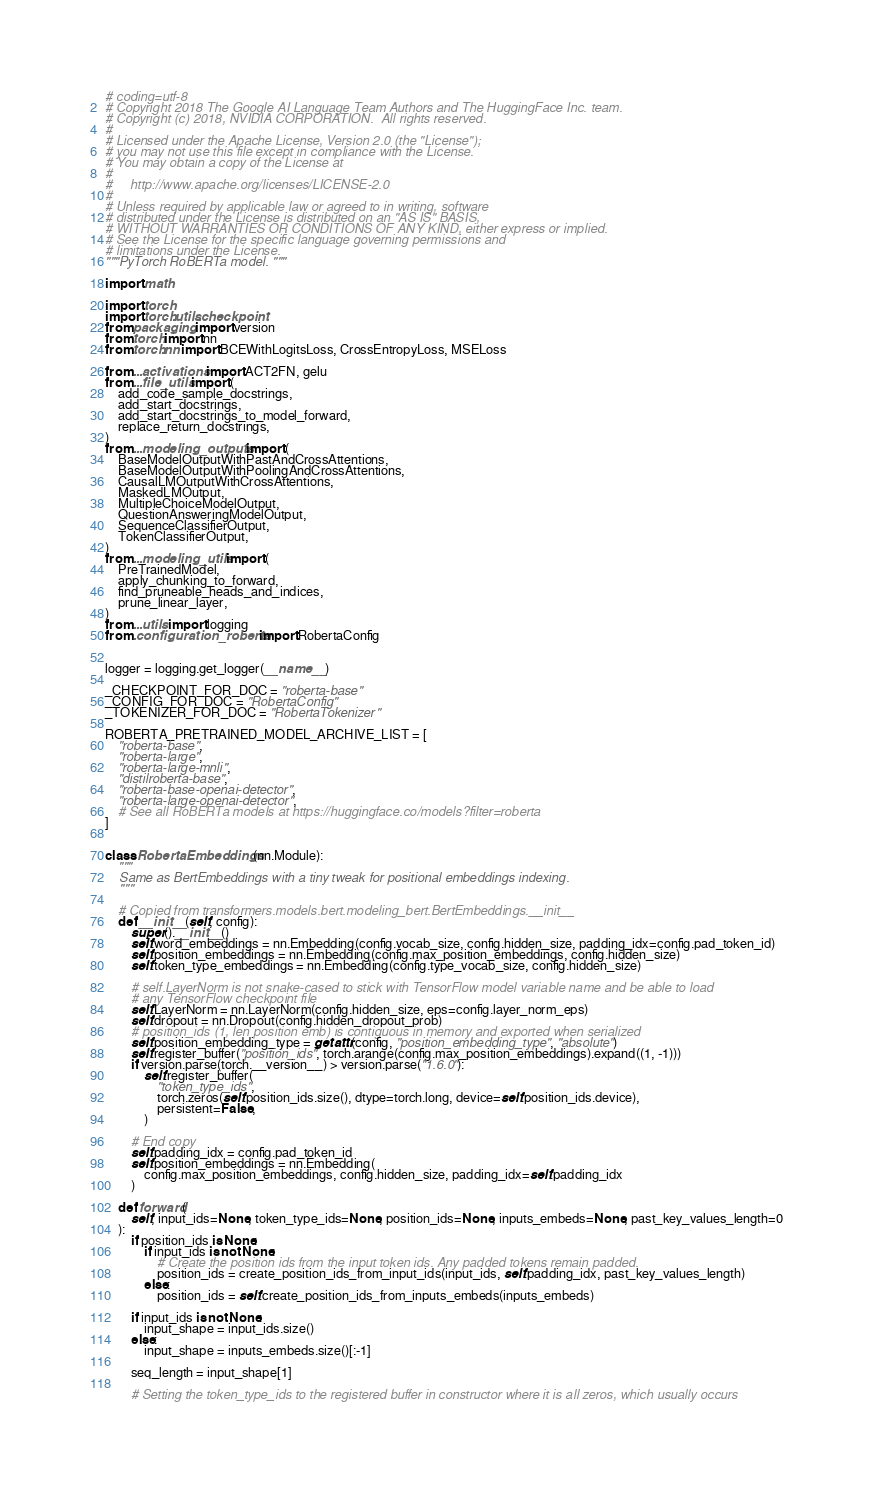<code> <loc_0><loc_0><loc_500><loc_500><_Python_># coding=utf-8
# Copyright 2018 The Google AI Language Team Authors and The HuggingFace Inc. team.
# Copyright (c) 2018, NVIDIA CORPORATION.  All rights reserved.
#
# Licensed under the Apache License, Version 2.0 (the "License");
# you may not use this file except in compliance with the License.
# You may obtain a copy of the License at
#
#     http://www.apache.org/licenses/LICENSE-2.0
#
# Unless required by applicable law or agreed to in writing, software
# distributed under the License is distributed on an "AS IS" BASIS,
# WITHOUT WARRANTIES OR CONDITIONS OF ANY KIND, either express or implied.
# See the License for the specific language governing permissions and
# limitations under the License.
"""PyTorch RoBERTa model. """

import math

import torch
import torch.utils.checkpoint
from packaging import version
from torch import nn
from torch.nn import BCEWithLogitsLoss, CrossEntropyLoss, MSELoss

from ...activations import ACT2FN, gelu
from ...file_utils import (
    add_code_sample_docstrings,
    add_start_docstrings,
    add_start_docstrings_to_model_forward,
    replace_return_docstrings,
)
from ...modeling_outputs import (
    BaseModelOutputWithPastAndCrossAttentions,
    BaseModelOutputWithPoolingAndCrossAttentions,
    CausalLMOutputWithCrossAttentions,
    MaskedLMOutput,
    MultipleChoiceModelOutput,
    QuestionAnsweringModelOutput,
    SequenceClassifierOutput,
    TokenClassifierOutput,
)
from ...modeling_utils import (
    PreTrainedModel,
    apply_chunking_to_forward,
    find_pruneable_heads_and_indices,
    prune_linear_layer,
)
from ...utils import logging
from .configuration_roberta import RobertaConfig


logger = logging.get_logger(__name__)

_CHECKPOINT_FOR_DOC = "roberta-base"
_CONFIG_FOR_DOC = "RobertaConfig"
_TOKENIZER_FOR_DOC = "RobertaTokenizer"

ROBERTA_PRETRAINED_MODEL_ARCHIVE_LIST = [
    "roberta-base",
    "roberta-large",
    "roberta-large-mnli",
    "distilroberta-base",
    "roberta-base-openai-detector",
    "roberta-large-openai-detector",
    # See all RoBERTa models at https://huggingface.co/models?filter=roberta
]


class RobertaEmbeddings(nn.Module):
    """
    Same as BertEmbeddings with a tiny tweak for positional embeddings indexing.
    """

    # Copied from transformers.models.bert.modeling_bert.BertEmbeddings.__init__
    def __init__(self, config):
        super().__init__()
        self.word_embeddings = nn.Embedding(config.vocab_size, config.hidden_size, padding_idx=config.pad_token_id)
        self.position_embeddings = nn.Embedding(config.max_position_embeddings, config.hidden_size)
        self.token_type_embeddings = nn.Embedding(config.type_vocab_size, config.hidden_size)

        # self.LayerNorm is not snake-cased to stick with TensorFlow model variable name and be able to load
        # any TensorFlow checkpoint file
        self.LayerNorm = nn.LayerNorm(config.hidden_size, eps=config.layer_norm_eps)
        self.dropout = nn.Dropout(config.hidden_dropout_prob)
        # position_ids (1, len position emb) is contiguous in memory and exported when serialized
        self.position_embedding_type = getattr(config, "position_embedding_type", "absolute")
        self.register_buffer("position_ids", torch.arange(config.max_position_embeddings).expand((1, -1)))
        if version.parse(torch.__version__) > version.parse("1.6.0"):
            self.register_buffer(
                "token_type_ids",
                torch.zeros(self.position_ids.size(), dtype=torch.long, device=self.position_ids.device),
                persistent=False,
            )

        # End copy
        self.padding_idx = config.pad_token_id
        self.position_embeddings = nn.Embedding(
            config.max_position_embeddings, config.hidden_size, padding_idx=self.padding_idx
        )

    def forward(
        self, input_ids=None, token_type_ids=None, position_ids=None, inputs_embeds=None, past_key_values_length=0
    ):
        if position_ids is None:
            if input_ids is not None:
                # Create the position ids from the input token ids. Any padded tokens remain padded.
                position_ids = create_position_ids_from_input_ids(input_ids, self.padding_idx, past_key_values_length)
            else:
                position_ids = self.create_position_ids_from_inputs_embeds(inputs_embeds)

        if input_ids is not None:
            input_shape = input_ids.size()
        else:
            input_shape = inputs_embeds.size()[:-1]

        seq_length = input_shape[1]

        # Setting the token_type_ids to the registered buffer in constructor where it is all zeros, which usually occurs</code> 